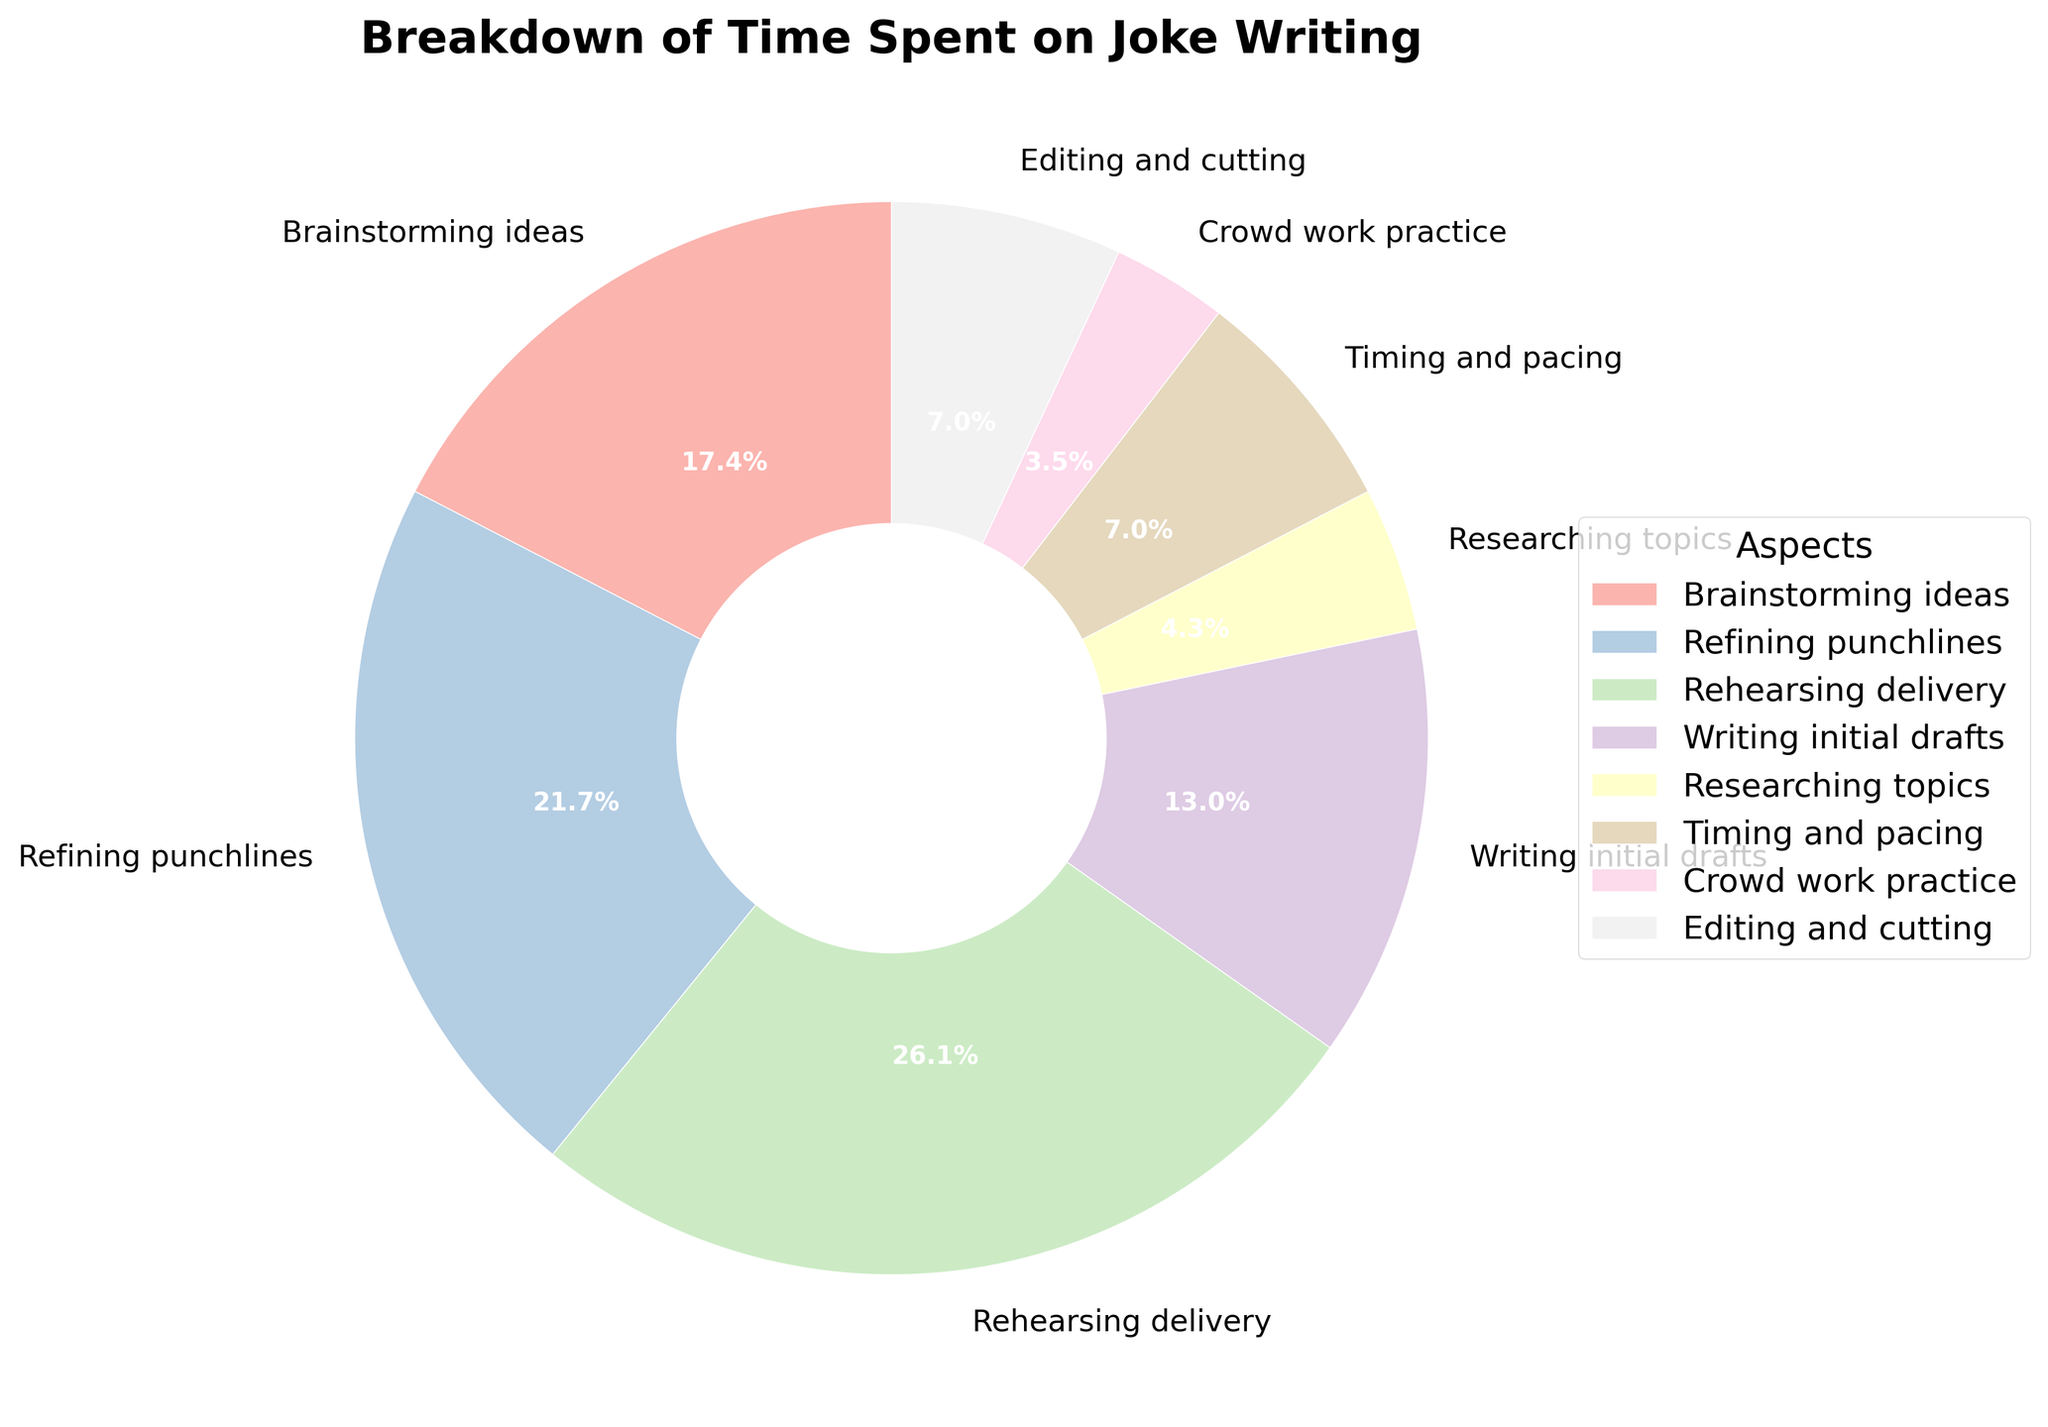Which aspect of joke writing takes up the largest percentage of time? By observing the pie chart, we can identify the largest section, which is "Rehearsing delivery" at 30%. Therefore, rehearsing delivery takes up the largest percentage of time.
Answer: Rehearsing delivery Which two aspects of joke writing together take up less than Timing and pacing? We observe that "Crowd work practice" is 4% and "Researching topics" is 5%. Adding these two gives us 4% + 5% = 9%, which is more than "Timing and pacing" at 8%. Therefore, none fit. However, adding "Editing and cutting" (8%) and any smaller percentage would fit.
Answer: Crowd work practice and Researching topics What's the combined percentage of time spent on refining punchlines and writing initial drafts? From the pie chart, "Refining punchlines" is 25% and "Writing initial drafts" is 15%. Adding these together: 25% + 15% = 40%.
Answer: 40% Is more time spent on brainstorming ideas or on researching topics? We observe the percentages for "Brainstorming ideas" and "Researching topics" are 20% and 5%, respectively. Therefore, more time is spent on brainstorming ideas.
Answer: Brainstorming ideas How much more time, in percentage points, is spent on rehearsing delivery compared to crowd work practice? Rehearsing delivery takes 30%, while crowd work practice takes 4%. The difference is 30% - 4% = 26%.
Answer: 26% What is the average percentage of time spent on brainstorming ideas, timing and pacing, and editing and cutting? Summing the percentages for these aspects: 20% + 8% + 8% = 36%. The average is 36% / 3 = 12%.
Answer: 12% What is the most prominent color used in the section representing refining punchlines? By observing the pie chart, the section for "Refining punchlines" (25%) is noted to be in the pastel color palette, specifically a prominent pastel shade (e.g., pastel red).
Answer: Pastel red Which aspect has the smallest percentage, and what is that percentage? The smallest section in the pie chart is "Crowd work practice," at 4%.
Answer: Crowd work practice, 4% Is the sum of time spent on editing and cutting and timing and pacing greater than that on refining punchlines? "Editing and cutting" is 8% and "Timing and pacing" is 8%. Combined, they total: 8% + 8% = 16%, which is less than "Refining punchlines" at 25%.
Answer: No How much more percentage of time is allocated to writing initial drafts compared to crowd work practice? "Writing initial drafts" takes up 15%, and "Crowd work practice" is 4%. The difference is 15% - 4% = 11%.
Answer: 11% 